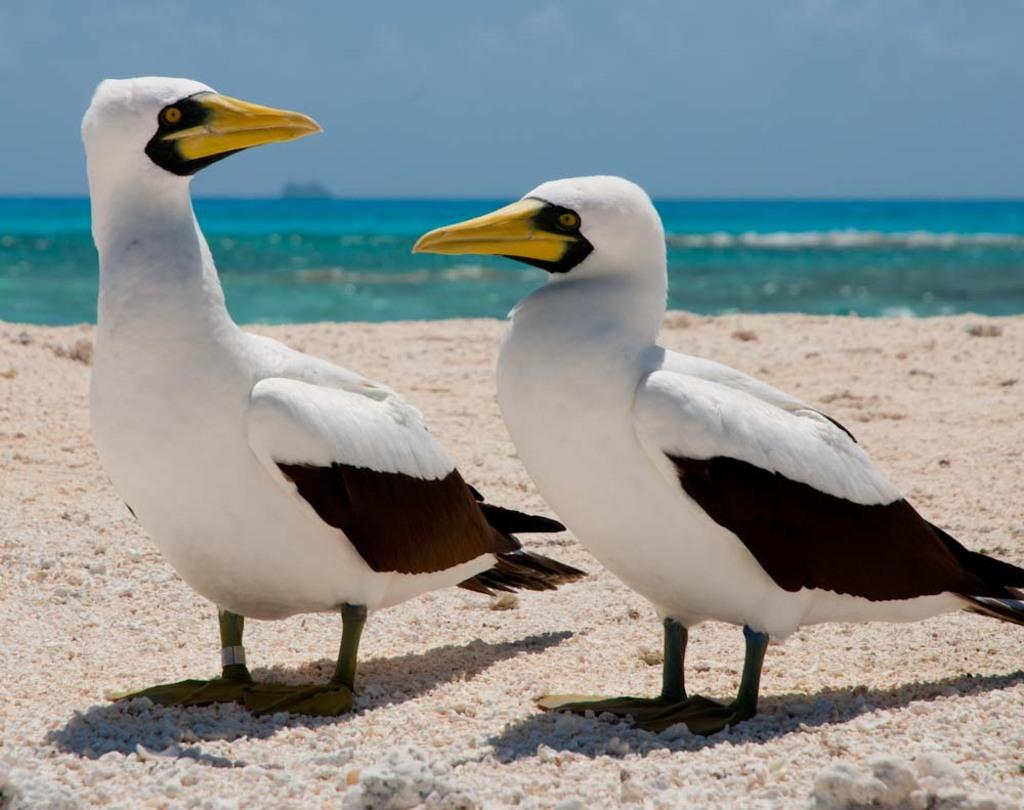What type of animals can be seen in the image? There are two white birds in the image. Where are the birds located? The birds are standing on the sand. What can be seen in the background of the image? There is water visible in the background of the image. What is visible at the top of the image? The sky is visible at the top of the image. What type of office furniture can be seen in the image? There is no office furniture present in the image; it features two white birds standing on the sand. What impulse might the birds have in the image? The image does not provide information about the birds' impulses or motivations. 